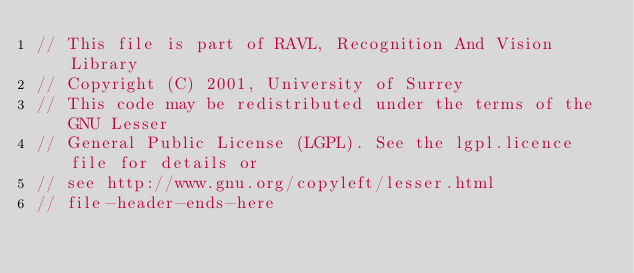<code> <loc_0><loc_0><loc_500><loc_500><_C++_>// This file is part of RAVL, Recognition And Vision Library 
// Copyright (C) 2001, University of Surrey
// This code may be redistributed under the terms of the GNU Lesser
// General Public License (LGPL). See the lgpl.licence file for details or
// see http://www.gnu.org/copyleft/lesser.html
// file-header-ends-here</code> 